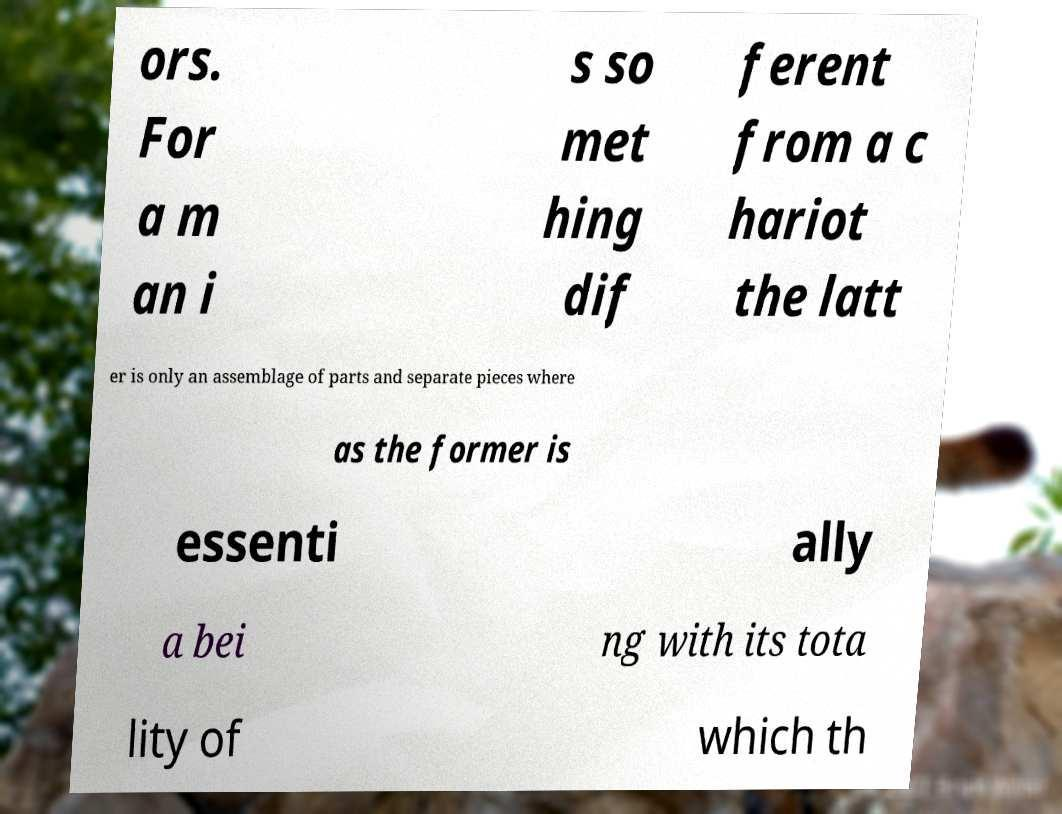Please identify and transcribe the text found in this image. ors. For a m an i s so met hing dif ferent from a c hariot the latt er is only an assemblage of parts and separate pieces where as the former is essenti ally a bei ng with its tota lity of which th 